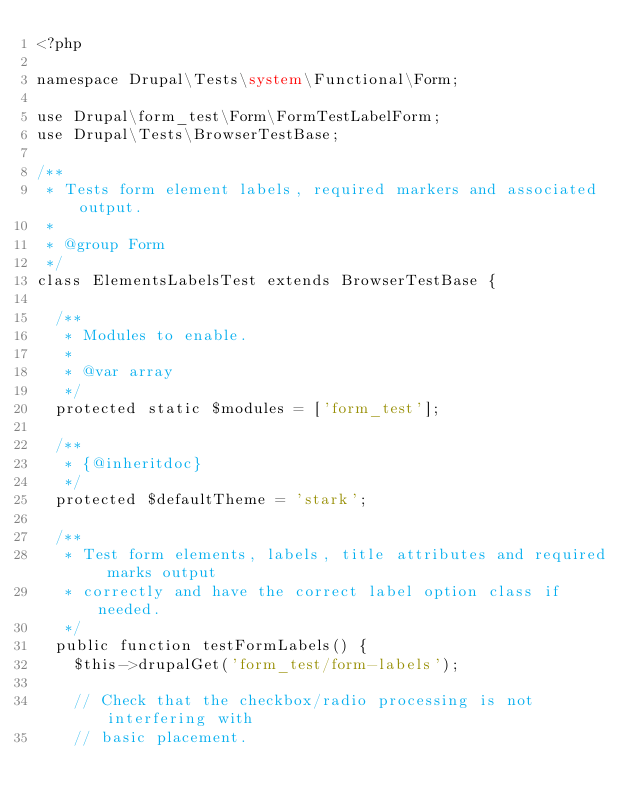Convert code to text. <code><loc_0><loc_0><loc_500><loc_500><_PHP_><?php

namespace Drupal\Tests\system\Functional\Form;

use Drupal\form_test\Form\FormTestLabelForm;
use Drupal\Tests\BrowserTestBase;

/**
 * Tests form element labels, required markers and associated output.
 *
 * @group Form
 */
class ElementsLabelsTest extends BrowserTestBase {

  /**
   * Modules to enable.
   *
   * @var array
   */
  protected static $modules = ['form_test'];

  /**
   * {@inheritdoc}
   */
  protected $defaultTheme = 'stark';

  /**
   * Test form elements, labels, title attributes and required marks output
   * correctly and have the correct label option class if needed.
   */
  public function testFormLabels() {
    $this->drupalGet('form_test/form-labels');

    // Check that the checkbox/radio processing is not interfering with
    // basic placement.</code> 